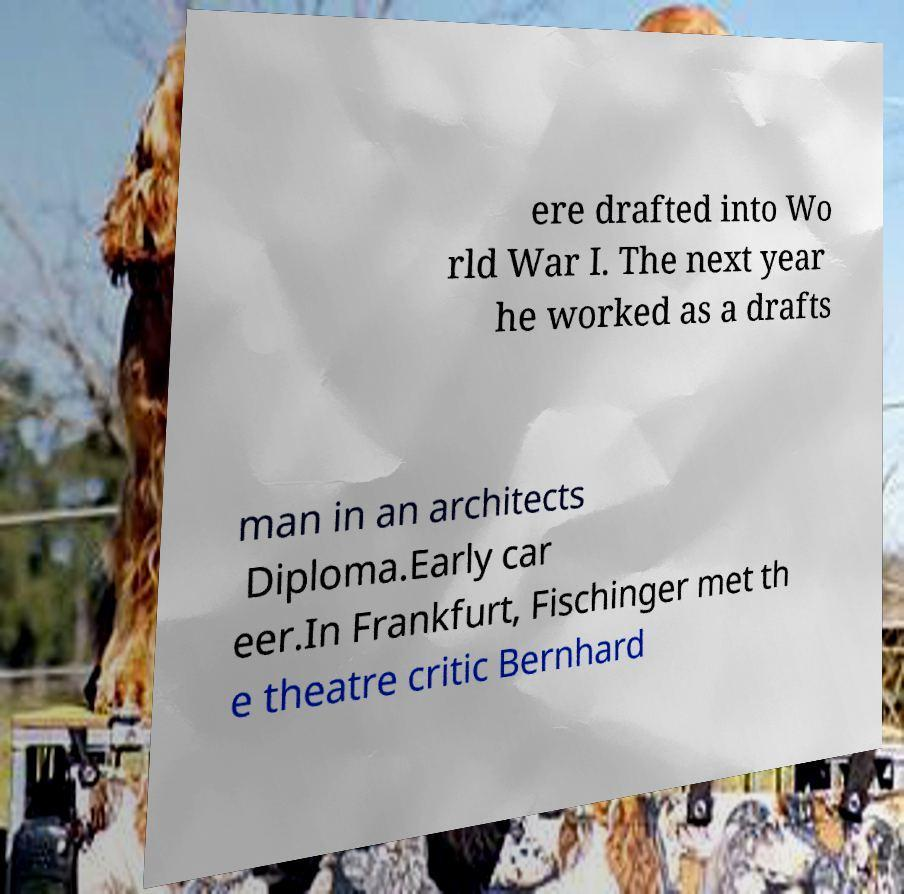There's text embedded in this image that I need extracted. Can you transcribe it verbatim? ere drafted into Wo rld War I. The next year he worked as a drafts man in an architects Diploma.Early car eer.In Frankfurt, Fischinger met th e theatre critic Bernhard 